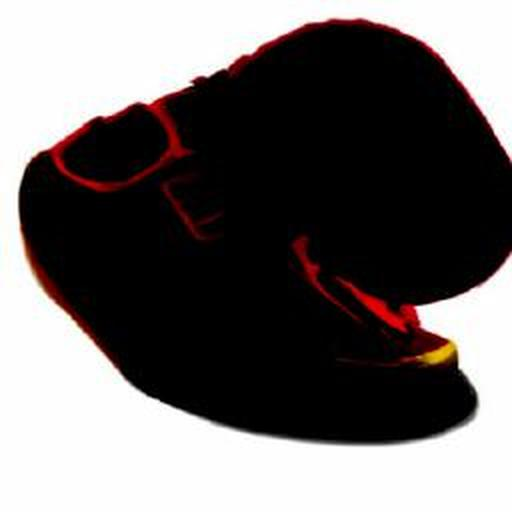What is the clarity of the image? The image clarity is quite low, with significant blurriness and lack of detail that prevents clear identification of specific features or objects presented. 